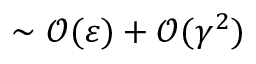Convert formula to latex. <formula><loc_0><loc_0><loc_500><loc_500>\sim \mathcal { O } ( \varepsilon ) + \mathcal { O } ( \gamma ^ { 2 } )</formula> 